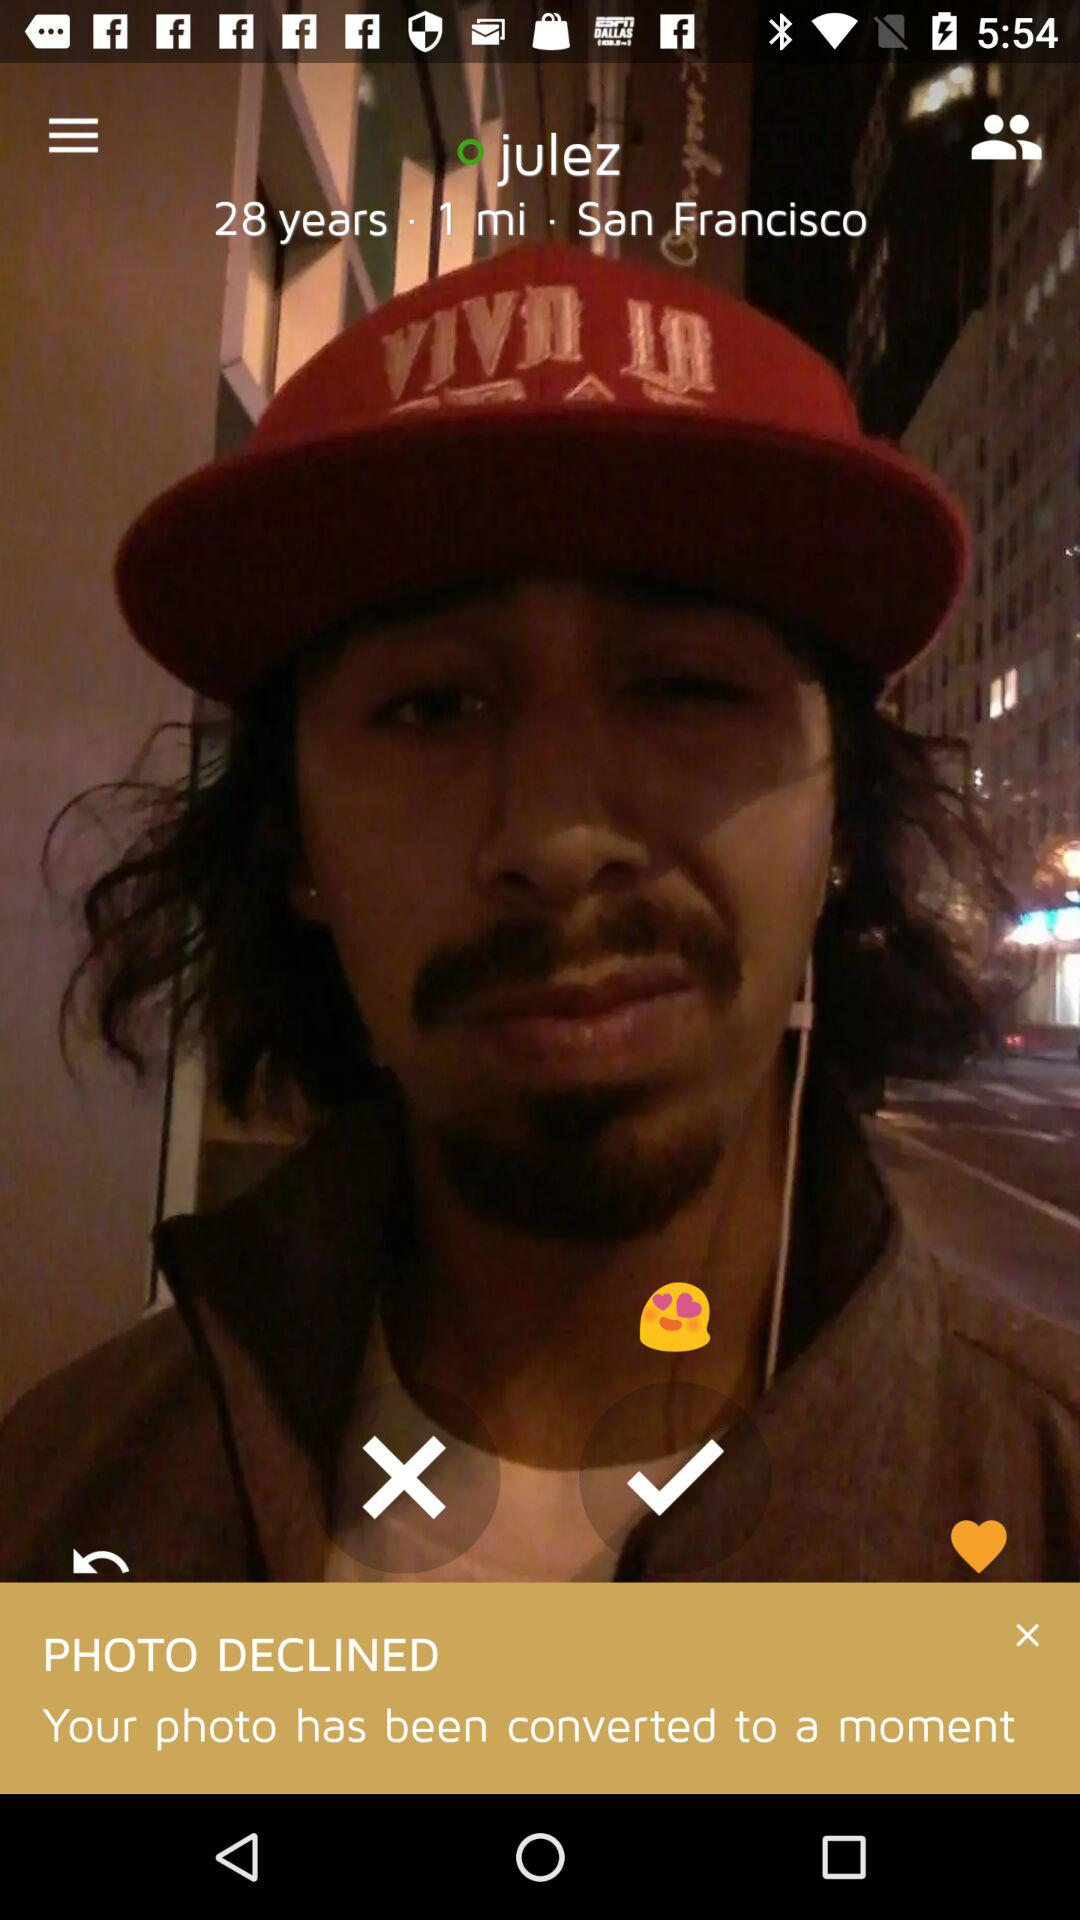At which location this photo was clicked?
When the provided information is insufficient, respond with <no answer>. <no answer> 